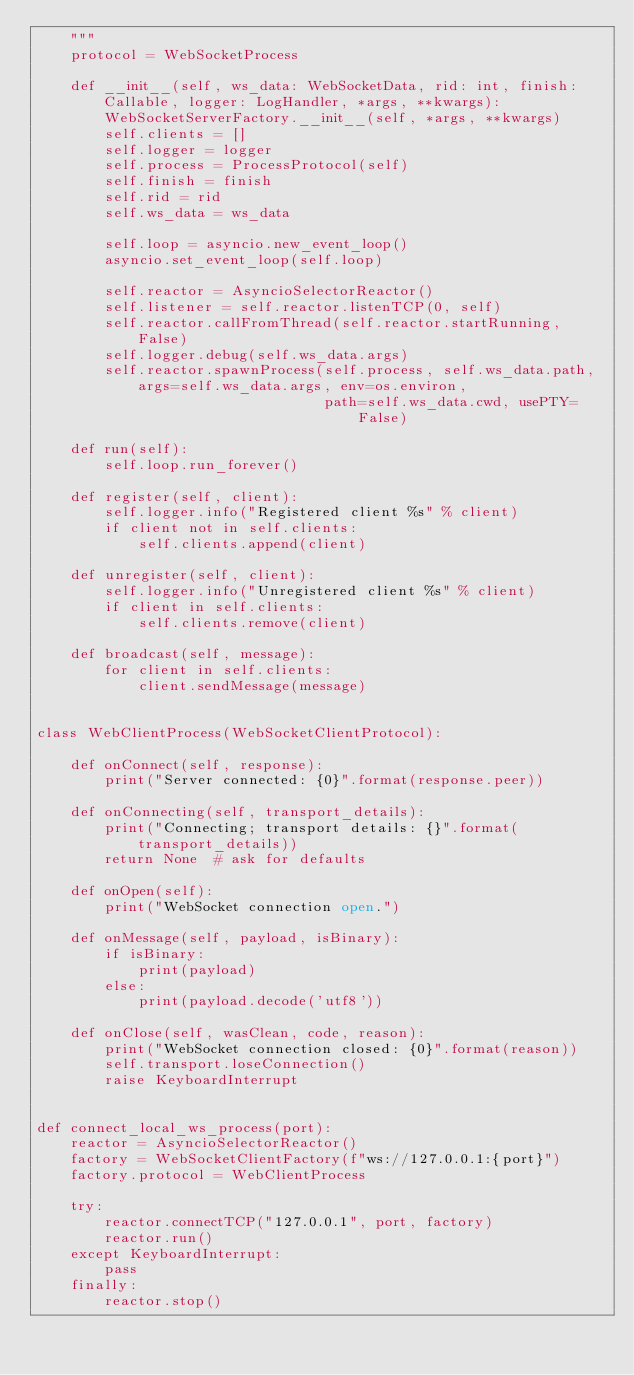<code> <loc_0><loc_0><loc_500><loc_500><_Python_>    """
    protocol = WebSocketProcess

    def __init__(self, ws_data: WebSocketData, rid: int, finish: Callable, logger: LogHandler, *args, **kwargs):
        WebSocketServerFactory.__init__(self, *args, **kwargs)
        self.clients = []
        self.logger = logger
        self.process = ProcessProtocol(self)
        self.finish = finish
        self.rid = rid
        self.ws_data = ws_data

        self.loop = asyncio.new_event_loop()
        asyncio.set_event_loop(self.loop)

        self.reactor = AsyncioSelectorReactor()
        self.listener = self.reactor.listenTCP(0, self)
        self.reactor.callFromThread(self.reactor.startRunning, False)
        self.logger.debug(self.ws_data.args)
        self.reactor.spawnProcess(self.process, self.ws_data.path, args=self.ws_data.args, env=os.environ,
                                  path=self.ws_data.cwd, usePTY=False)

    def run(self):
        self.loop.run_forever()

    def register(self, client):
        self.logger.info("Registered client %s" % client)
        if client not in self.clients:
            self.clients.append(client)

    def unregister(self, client):
        self.logger.info("Unregistered client %s" % client)
        if client in self.clients:
            self.clients.remove(client)

    def broadcast(self, message):
        for client in self.clients:
            client.sendMessage(message)


class WebClientProcess(WebSocketClientProtocol):

    def onConnect(self, response):
        print("Server connected: {0}".format(response.peer))

    def onConnecting(self, transport_details):
        print("Connecting; transport details: {}".format(transport_details))
        return None  # ask for defaults

    def onOpen(self):
        print("WebSocket connection open.")

    def onMessage(self, payload, isBinary):
        if isBinary:
            print(payload)
        else:
            print(payload.decode('utf8'))

    def onClose(self, wasClean, code, reason):
        print("WebSocket connection closed: {0}".format(reason))
        self.transport.loseConnection()
        raise KeyboardInterrupt


def connect_local_ws_process(port):
    reactor = AsyncioSelectorReactor()
    factory = WebSocketClientFactory(f"ws://127.0.0.1:{port}")
    factory.protocol = WebClientProcess

    try:
        reactor.connectTCP("127.0.0.1", port, factory)
        reactor.run()
    except KeyboardInterrupt:
        pass
    finally:
        reactor.stop()
</code> 